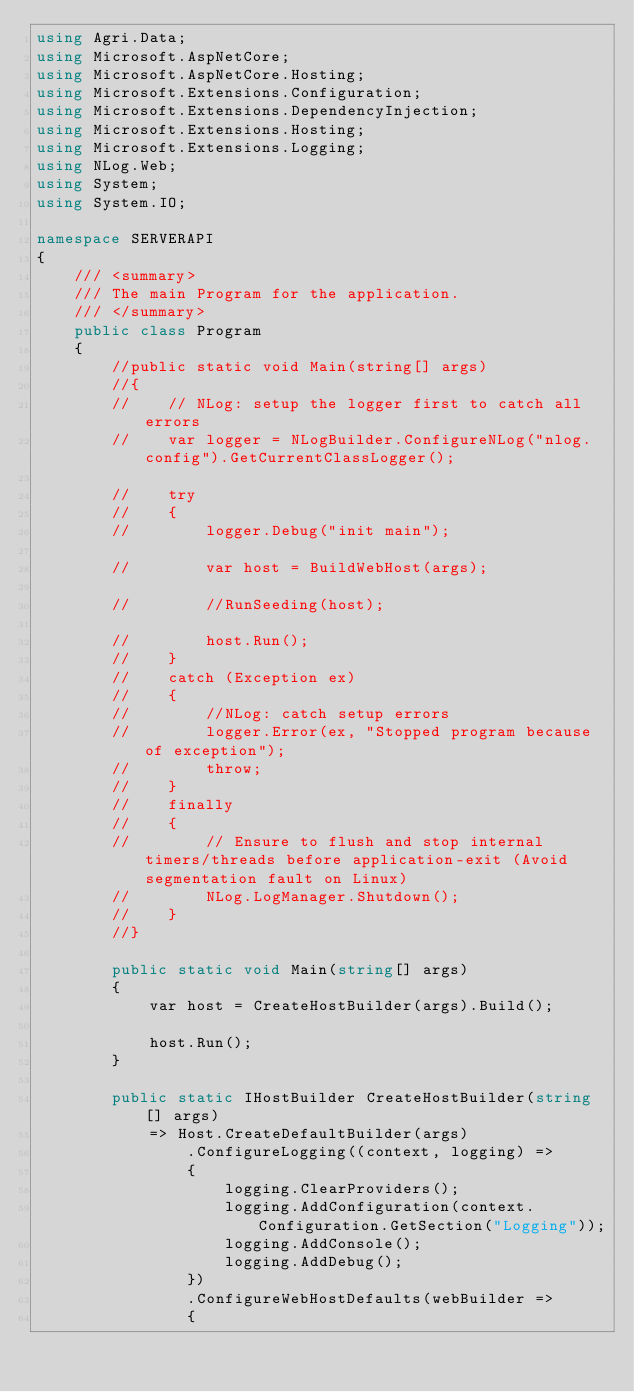<code> <loc_0><loc_0><loc_500><loc_500><_C#_>using Agri.Data;
using Microsoft.AspNetCore;
using Microsoft.AspNetCore.Hosting;
using Microsoft.Extensions.Configuration;
using Microsoft.Extensions.DependencyInjection;
using Microsoft.Extensions.Hosting;
using Microsoft.Extensions.Logging;
using NLog.Web;
using System;
using System.IO;

namespace SERVERAPI
{
    /// <summary>
    /// The main Program for the application.
    /// </summary>
    public class Program
    {
        //public static void Main(string[] args)
        //{
        //    // NLog: setup the logger first to catch all errors
        //    var logger = NLogBuilder.ConfigureNLog("nlog.config").GetCurrentClassLogger();

        //    try
        //    {
        //        logger.Debug("init main");

        //        var host = BuildWebHost(args);

        //        //RunSeeding(host);

        //        host.Run();
        //    }
        //    catch (Exception ex)
        //    {
        //        //NLog: catch setup errors
        //        logger.Error(ex, "Stopped program because of exception");
        //        throw;
        //    }
        //    finally
        //    {
        //        // Ensure to flush and stop internal timers/threads before application-exit (Avoid segmentation fault on Linux)
        //        NLog.LogManager.Shutdown();
        //    }
        //}

        public static void Main(string[] args)
        {
            var host = CreateHostBuilder(args).Build();

            host.Run();
        }

        public static IHostBuilder CreateHostBuilder(string[] args)
            => Host.CreateDefaultBuilder(args)
                .ConfigureLogging((context, logging) =>
                {
                    logging.ClearProviders();
                    logging.AddConfiguration(context.Configuration.GetSection("Logging"));
                    logging.AddConsole();
                    logging.AddDebug();
                })
                .ConfigureWebHostDefaults(webBuilder =>
                {</code> 